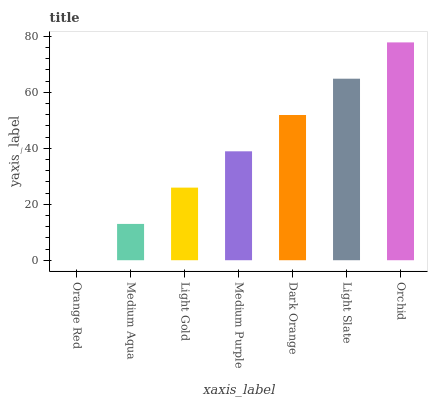Is Orange Red the minimum?
Answer yes or no. Yes. Is Orchid the maximum?
Answer yes or no. Yes. Is Medium Aqua the minimum?
Answer yes or no. No. Is Medium Aqua the maximum?
Answer yes or no. No. Is Medium Aqua greater than Orange Red?
Answer yes or no. Yes. Is Orange Red less than Medium Aqua?
Answer yes or no. Yes. Is Orange Red greater than Medium Aqua?
Answer yes or no. No. Is Medium Aqua less than Orange Red?
Answer yes or no. No. Is Medium Purple the high median?
Answer yes or no. Yes. Is Medium Purple the low median?
Answer yes or no. Yes. Is Orchid the high median?
Answer yes or no. No. Is Light Gold the low median?
Answer yes or no. No. 